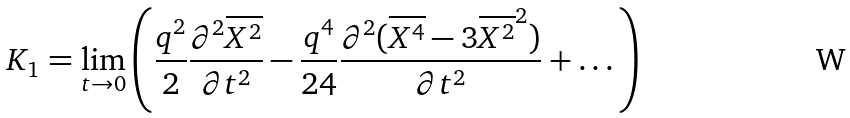Convert formula to latex. <formula><loc_0><loc_0><loc_500><loc_500>K _ { 1 } = \lim _ { t \rightarrow 0 } \left ( \frac { q ^ { 2 } } { 2 } \frac { \partial ^ { 2 } \overline { X ^ { 2 } } } { \partial t ^ { 2 } } - \frac { q ^ { 4 } } { 2 4 } \frac { \partial ^ { 2 } ( \overline { X ^ { 4 } } - 3 \overline { X ^ { 2 } } ^ { 2 } ) } { \partial t ^ { 2 } } + \dots \right )</formula> 